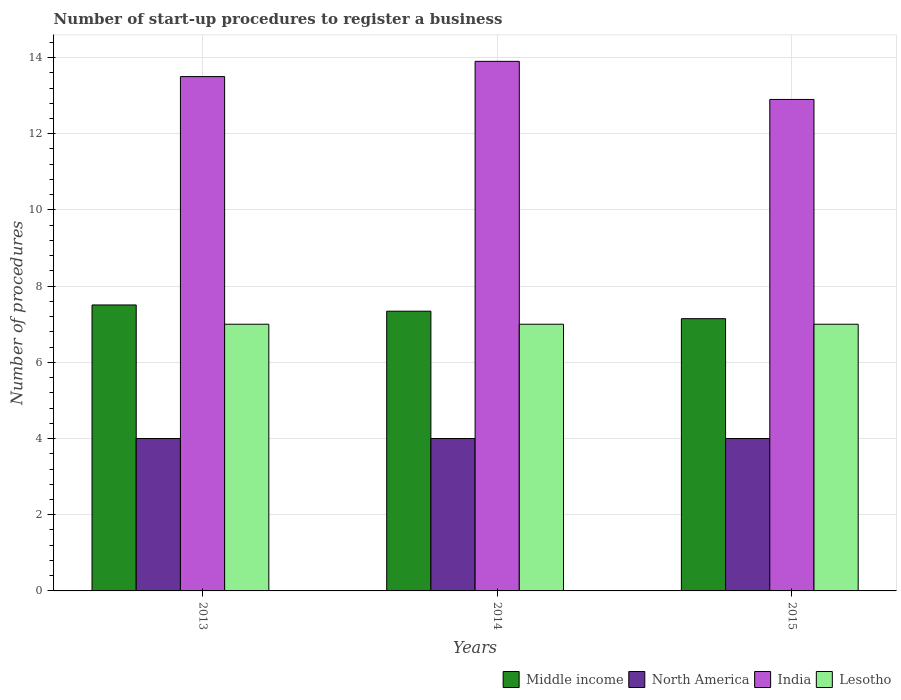How many different coloured bars are there?
Ensure brevity in your answer.  4. How many groups of bars are there?
Provide a succinct answer. 3. Are the number of bars on each tick of the X-axis equal?
Make the answer very short. Yes. What is the label of the 1st group of bars from the left?
Your answer should be compact. 2013. What is the number of procedures required to register a business in North America in 2015?
Keep it short and to the point. 4. Across all years, what is the maximum number of procedures required to register a business in Lesotho?
Provide a short and direct response. 7. Across all years, what is the minimum number of procedures required to register a business in Middle income?
Your answer should be very brief. 7.15. What is the total number of procedures required to register a business in Middle income in the graph?
Provide a succinct answer. 21.99. What is the difference between the number of procedures required to register a business in Lesotho in 2014 and that in 2015?
Give a very brief answer. 0. What is the difference between the number of procedures required to register a business in India in 2015 and the number of procedures required to register a business in Middle income in 2013?
Provide a succinct answer. 5.39. What is the average number of procedures required to register a business in North America per year?
Keep it short and to the point. 4. In the year 2013, what is the difference between the number of procedures required to register a business in Lesotho and number of procedures required to register a business in Middle income?
Give a very brief answer. -0.51. In how many years, is the number of procedures required to register a business in North America greater than 8.4?
Your answer should be compact. 0. What is the ratio of the number of procedures required to register a business in Lesotho in 2013 to that in 2014?
Offer a terse response. 1. Is the number of procedures required to register a business in India in 2013 less than that in 2015?
Make the answer very short. No. Is the difference between the number of procedures required to register a business in Lesotho in 2013 and 2015 greater than the difference between the number of procedures required to register a business in Middle income in 2013 and 2015?
Make the answer very short. No. What is the difference between the highest and the second highest number of procedures required to register a business in Middle income?
Your answer should be compact. 0.16. Is the sum of the number of procedures required to register a business in Middle income in 2014 and 2015 greater than the maximum number of procedures required to register a business in India across all years?
Your response must be concise. Yes. What does the 4th bar from the left in 2013 represents?
Provide a short and direct response. Lesotho. How many bars are there?
Offer a very short reply. 12. How many years are there in the graph?
Give a very brief answer. 3. What is the difference between two consecutive major ticks on the Y-axis?
Provide a short and direct response. 2. Where does the legend appear in the graph?
Ensure brevity in your answer.  Bottom right. How many legend labels are there?
Offer a terse response. 4. How are the legend labels stacked?
Keep it short and to the point. Horizontal. What is the title of the graph?
Offer a terse response. Number of start-up procedures to register a business. What is the label or title of the Y-axis?
Provide a succinct answer. Number of procedures. What is the Number of procedures of Middle income in 2013?
Your answer should be very brief. 7.51. What is the Number of procedures of India in 2013?
Give a very brief answer. 13.5. What is the Number of procedures of Lesotho in 2013?
Offer a very short reply. 7. What is the Number of procedures of Middle income in 2014?
Make the answer very short. 7.34. What is the Number of procedures in India in 2014?
Give a very brief answer. 13.9. What is the Number of procedures of Middle income in 2015?
Make the answer very short. 7.15. What is the Number of procedures of North America in 2015?
Give a very brief answer. 4. Across all years, what is the maximum Number of procedures of Middle income?
Keep it short and to the point. 7.51. Across all years, what is the maximum Number of procedures of Lesotho?
Your answer should be very brief. 7. Across all years, what is the minimum Number of procedures in Middle income?
Your answer should be compact. 7.15. Across all years, what is the minimum Number of procedures in North America?
Your answer should be compact. 4. Across all years, what is the minimum Number of procedures of India?
Offer a terse response. 12.9. What is the total Number of procedures in Middle income in the graph?
Make the answer very short. 21.99. What is the total Number of procedures in India in the graph?
Offer a terse response. 40.3. What is the total Number of procedures in Lesotho in the graph?
Make the answer very short. 21. What is the difference between the Number of procedures of Middle income in 2013 and that in 2014?
Your answer should be compact. 0.16. What is the difference between the Number of procedures of India in 2013 and that in 2014?
Keep it short and to the point. -0.4. What is the difference between the Number of procedures of Middle income in 2013 and that in 2015?
Ensure brevity in your answer.  0.36. What is the difference between the Number of procedures of North America in 2013 and that in 2015?
Provide a succinct answer. 0. What is the difference between the Number of procedures in Middle income in 2014 and that in 2015?
Your answer should be very brief. 0.2. What is the difference between the Number of procedures in North America in 2014 and that in 2015?
Your answer should be very brief. 0. What is the difference between the Number of procedures of India in 2014 and that in 2015?
Offer a terse response. 1. What is the difference between the Number of procedures in Lesotho in 2014 and that in 2015?
Your response must be concise. 0. What is the difference between the Number of procedures of Middle income in 2013 and the Number of procedures of North America in 2014?
Offer a very short reply. 3.51. What is the difference between the Number of procedures in Middle income in 2013 and the Number of procedures in India in 2014?
Provide a succinct answer. -6.39. What is the difference between the Number of procedures in Middle income in 2013 and the Number of procedures in Lesotho in 2014?
Offer a very short reply. 0.51. What is the difference between the Number of procedures in North America in 2013 and the Number of procedures in India in 2014?
Give a very brief answer. -9.9. What is the difference between the Number of procedures of India in 2013 and the Number of procedures of Lesotho in 2014?
Ensure brevity in your answer.  6.5. What is the difference between the Number of procedures in Middle income in 2013 and the Number of procedures in North America in 2015?
Give a very brief answer. 3.51. What is the difference between the Number of procedures of Middle income in 2013 and the Number of procedures of India in 2015?
Your response must be concise. -5.39. What is the difference between the Number of procedures of Middle income in 2013 and the Number of procedures of Lesotho in 2015?
Your answer should be compact. 0.51. What is the difference between the Number of procedures of North America in 2013 and the Number of procedures of Lesotho in 2015?
Offer a very short reply. -3. What is the difference between the Number of procedures of Middle income in 2014 and the Number of procedures of North America in 2015?
Your answer should be compact. 3.34. What is the difference between the Number of procedures in Middle income in 2014 and the Number of procedures in India in 2015?
Your response must be concise. -5.56. What is the difference between the Number of procedures in Middle income in 2014 and the Number of procedures in Lesotho in 2015?
Provide a short and direct response. 0.34. What is the average Number of procedures of Middle income per year?
Keep it short and to the point. 7.33. What is the average Number of procedures in India per year?
Your answer should be very brief. 13.43. In the year 2013, what is the difference between the Number of procedures in Middle income and Number of procedures in North America?
Offer a terse response. 3.51. In the year 2013, what is the difference between the Number of procedures of Middle income and Number of procedures of India?
Provide a succinct answer. -5.99. In the year 2013, what is the difference between the Number of procedures in Middle income and Number of procedures in Lesotho?
Your answer should be very brief. 0.51. In the year 2013, what is the difference between the Number of procedures of North America and Number of procedures of India?
Your response must be concise. -9.5. In the year 2013, what is the difference between the Number of procedures of North America and Number of procedures of Lesotho?
Keep it short and to the point. -3. In the year 2013, what is the difference between the Number of procedures of India and Number of procedures of Lesotho?
Give a very brief answer. 6.5. In the year 2014, what is the difference between the Number of procedures in Middle income and Number of procedures in North America?
Give a very brief answer. 3.34. In the year 2014, what is the difference between the Number of procedures in Middle income and Number of procedures in India?
Provide a short and direct response. -6.56. In the year 2014, what is the difference between the Number of procedures in Middle income and Number of procedures in Lesotho?
Your answer should be compact. 0.34. In the year 2014, what is the difference between the Number of procedures of North America and Number of procedures of Lesotho?
Your response must be concise. -3. In the year 2014, what is the difference between the Number of procedures of India and Number of procedures of Lesotho?
Provide a succinct answer. 6.9. In the year 2015, what is the difference between the Number of procedures of Middle income and Number of procedures of North America?
Ensure brevity in your answer.  3.15. In the year 2015, what is the difference between the Number of procedures of Middle income and Number of procedures of India?
Ensure brevity in your answer.  -5.75. In the year 2015, what is the difference between the Number of procedures of Middle income and Number of procedures of Lesotho?
Your answer should be compact. 0.15. In the year 2015, what is the difference between the Number of procedures of North America and Number of procedures of India?
Keep it short and to the point. -8.9. In the year 2015, what is the difference between the Number of procedures of North America and Number of procedures of Lesotho?
Offer a very short reply. -3. What is the ratio of the Number of procedures of Middle income in 2013 to that in 2014?
Give a very brief answer. 1.02. What is the ratio of the Number of procedures of India in 2013 to that in 2014?
Your response must be concise. 0.97. What is the ratio of the Number of procedures in Lesotho in 2013 to that in 2014?
Your answer should be compact. 1. What is the ratio of the Number of procedures in Middle income in 2013 to that in 2015?
Provide a short and direct response. 1.05. What is the ratio of the Number of procedures in India in 2013 to that in 2015?
Keep it short and to the point. 1.05. What is the ratio of the Number of procedures of Lesotho in 2013 to that in 2015?
Keep it short and to the point. 1. What is the ratio of the Number of procedures in Middle income in 2014 to that in 2015?
Give a very brief answer. 1.03. What is the ratio of the Number of procedures of North America in 2014 to that in 2015?
Offer a very short reply. 1. What is the ratio of the Number of procedures in India in 2014 to that in 2015?
Your response must be concise. 1.08. What is the ratio of the Number of procedures of Lesotho in 2014 to that in 2015?
Provide a succinct answer. 1. What is the difference between the highest and the second highest Number of procedures of Middle income?
Give a very brief answer. 0.16. What is the difference between the highest and the second highest Number of procedures in North America?
Make the answer very short. 0. What is the difference between the highest and the second highest Number of procedures of Lesotho?
Provide a short and direct response. 0. What is the difference between the highest and the lowest Number of procedures in Middle income?
Make the answer very short. 0.36. What is the difference between the highest and the lowest Number of procedures of India?
Keep it short and to the point. 1. What is the difference between the highest and the lowest Number of procedures of Lesotho?
Your answer should be very brief. 0. 